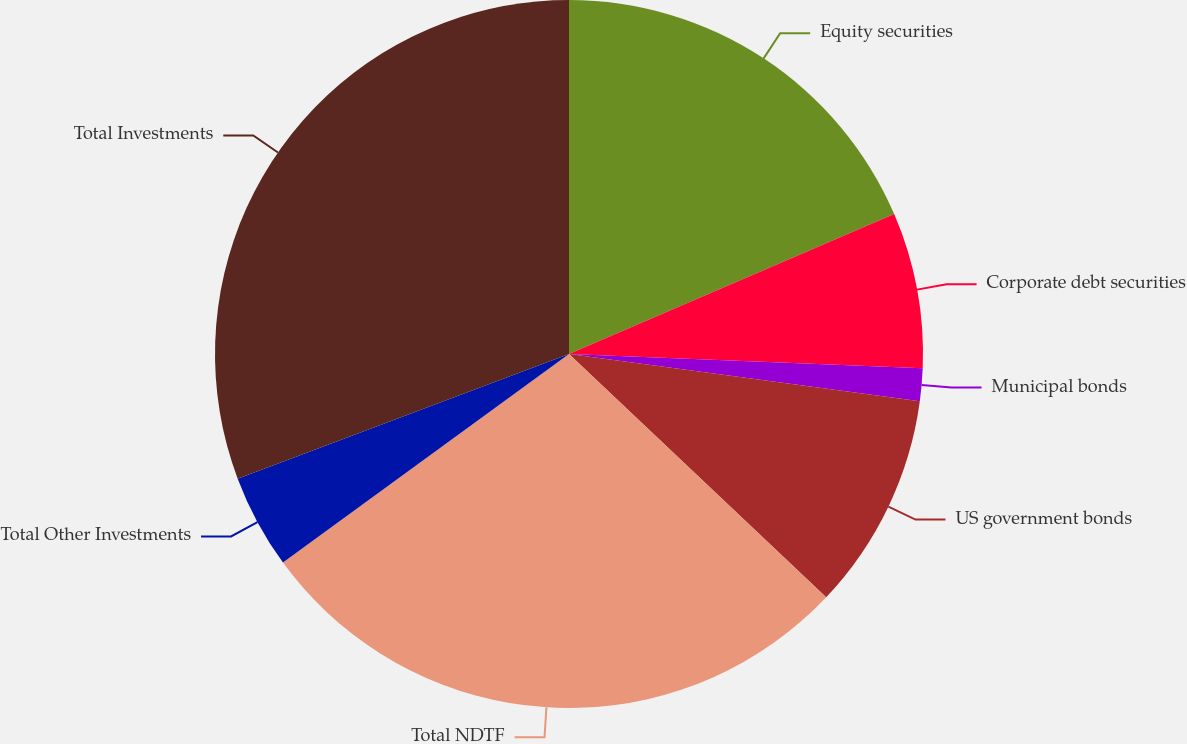Convert chart to OTSL. <chart><loc_0><loc_0><loc_500><loc_500><pie_chart><fcel>Equity securities<fcel>Corporate debt securities<fcel>Municipal bonds<fcel>US government bonds<fcel>Total NDTF<fcel>Total Other Investments<fcel>Total Investments<nl><fcel>18.53%<fcel>7.11%<fcel>1.49%<fcel>9.92%<fcel>27.91%<fcel>4.3%<fcel>30.72%<nl></chart> 